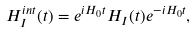Convert formula to latex. <formula><loc_0><loc_0><loc_500><loc_500>H _ { I } ^ { i n t } ( t ) = e ^ { i H _ { 0 } t } H _ { I } ( t ) e ^ { - i H _ { 0 } t } ,</formula> 